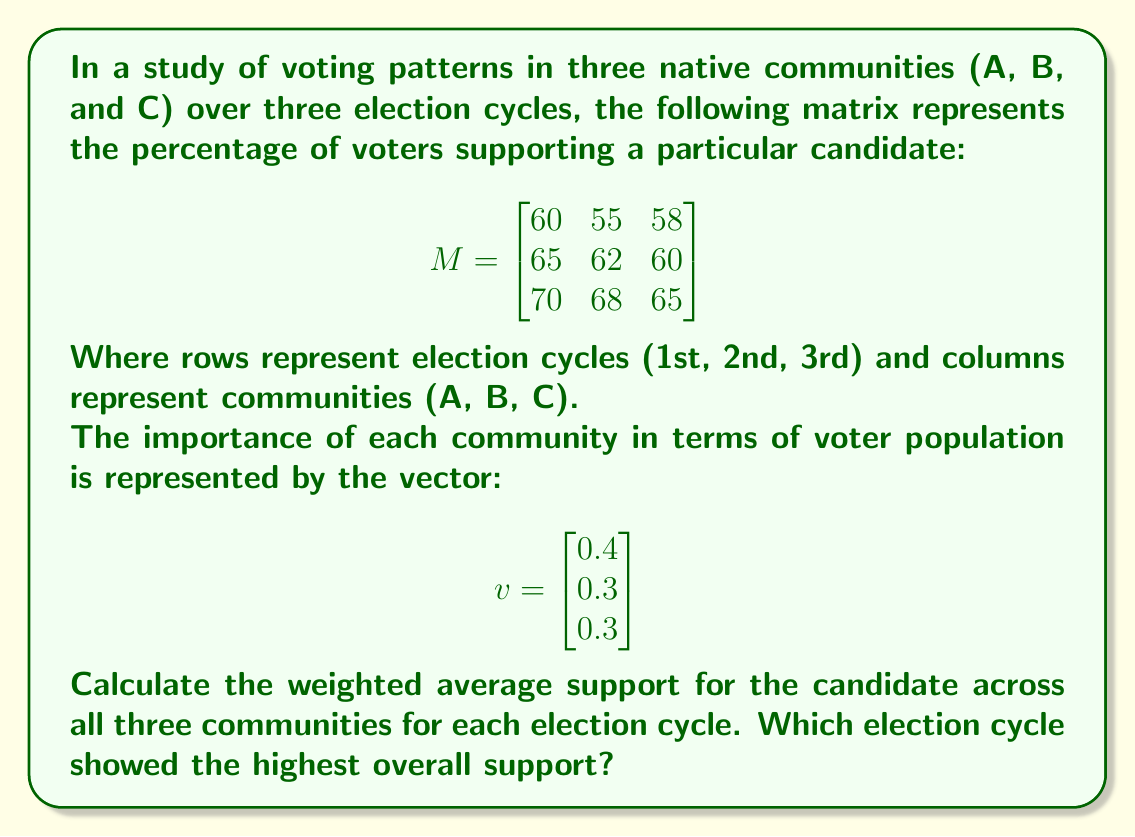Can you answer this question? To solve this problem, we need to perform matrix multiplication between the given matrix M and the vector v. This will give us a new vector representing the weighted average support for each election cycle.

Step 1: Perform matrix multiplication
$$Mv = \begin{bmatrix}
60 & 55 & 58 \\
65 & 62 & 60 \\
70 & 68 & 65
\end{bmatrix} \times \begin{bmatrix} 0.4 \\ 0.3 \\ 0.3 \end{bmatrix}$$

Step 2: Calculate each element of the resulting vector
First election cycle: 
$60(0.4) + 55(0.3) + 58(0.3) = 24 + 16.5 + 17.4 = 57.9$

Second election cycle:
$65(0.4) + 62(0.3) + 60(0.3) = 26 + 18.6 + 18 = 62.6$

Third election cycle:
$70(0.4) + 68(0.3) + 65(0.3) = 28 + 20.4 + 19.5 = 67.9$

Step 3: Write the resulting vector
$$Mv = \begin{bmatrix} 57.9 \\ 62.6 \\ 67.9 \end{bmatrix}$$

Step 4: Compare the results
The highest value in the resulting vector represents the election cycle with the highest overall support. In this case, it's the third election cycle with 67.9%.
Answer: The weighted average support for each election cycle is:
$$\begin{bmatrix} 57.9\% \\ 62.6\% \\ 67.9\% \end{bmatrix}$$
The third election cycle showed the highest overall support at 67.9%. 